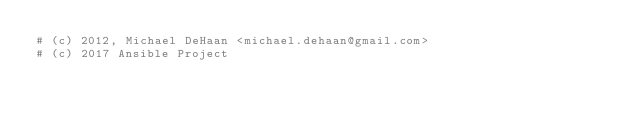Convert code to text. <code><loc_0><loc_0><loc_500><loc_500><_Python_># (c) 2012, Michael DeHaan <michael.dehaan@gmail.com>
# (c) 2017 Ansible Project</code> 